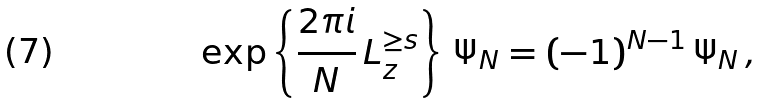<formula> <loc_0><loc_0><loc_500><loc_500>\exp \left \{ \frac { 2 \pi i } { N } \, L ^ { \geq s } _ { z } \right \} \, \Psi _ { N } = ( - 1 ) ^ { N - 1 } \, \Psi _ { N } \, ,</formula> 